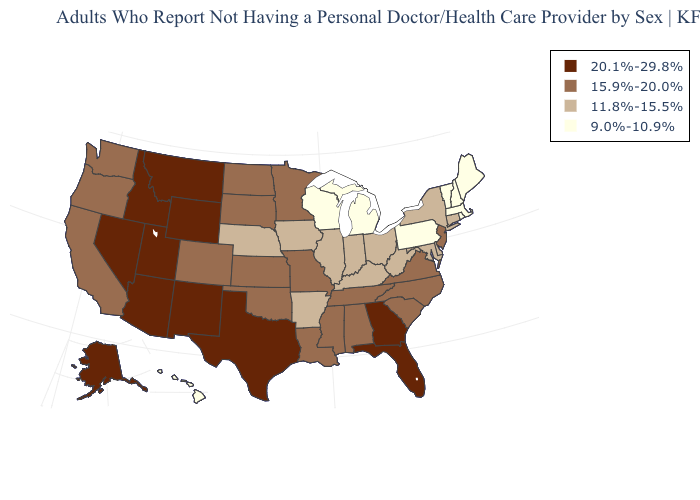Does New Jersey have a higher value than Utah?
Quick response, please. No. What is the value of Arizona?
Write a very short answer. 20.1%-29.8%. What is the value of Montana?
Short answer required. 20.1%-29.8%. What is the lowest value in the MidWest?
Answer briefly. 9.0%-10.9%. Does Arizona have the highest value in the USA?
Keep it brief. Yes. What is the highest value in the USA?
Answer briefly. 20.1%-29.8%. Does Indiana have a lower value than North Carolina?
Write a very short answer. Yes. Does the map have missing data?
Concise answer only. No. Name the states that have a value in the range 9.0%-10.9%?
Write a very short answer. Hawaii, Maine, Massachusetts, Michigan, New Hampshire, Pennsylvania, Rhode Island, Vermont, Wisconsin. Which states have the lowest value in the USA?
Be succinct. Hawaii, Maine, Massachusetts, Michigan, New Hampshire, Pennsylvania, Rhode Island, Vermont, Wisconsin. What is the value of Wisconsin?
Answer briefly. 9.0%-10.9%. Which states hav the highest value in the South?
Write a very short answer. Florida, Georgia, Texas. What is the value of Montana?
Concise answer only. 20.1%-29.8%. Name the states that have a value in the range 9.0%-10.9%?
Short answer required. Hawaii, Maine, Massachusetts, Michigan, New Hampshire, Pennsylvania, Rhode Island, Vermont, Wisconsin. Is the legend a continuous bar?
Give a very brief answer. No. 